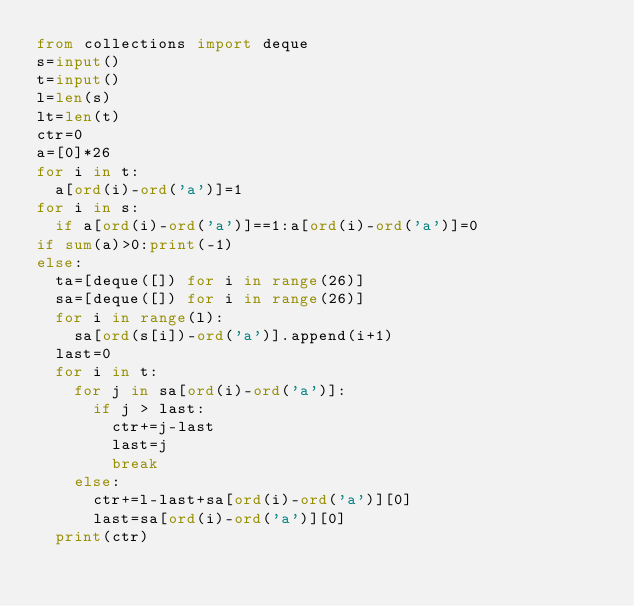<code> <loc_0><loc_0><loc_500><loc_500><_Python_>from collections import deque
s=input()
t=input()
l=len(s)
lt=len(t)
ctr=0
a=[0]*26
for i in t:
  a[ord(i)-ord('a')]=1
for i in s:
  if a[ord(i)-ord('a')]==1:a[ord(i)-ord('a')]=0
if sum(a)>0:print(-1)
else:
  ta=[deque([]) for i in range(26)]
  sa=[deque([]) for i in range(26)]
  for i in range(l):
    sa[ord(s[i])-ord('a')].append(i+1) 
  last=0
  for i in t:
    for j in sa[ord(i)-ord('a')]:
      if j > last:
        ctr+=j-last
        last=j
        break
    else:
      ctr+=l-last+sa[ord(i)-ord('a')][0]
      last=sa[ord(i)-ord('a')][0]
  print(ctr)
</code> 